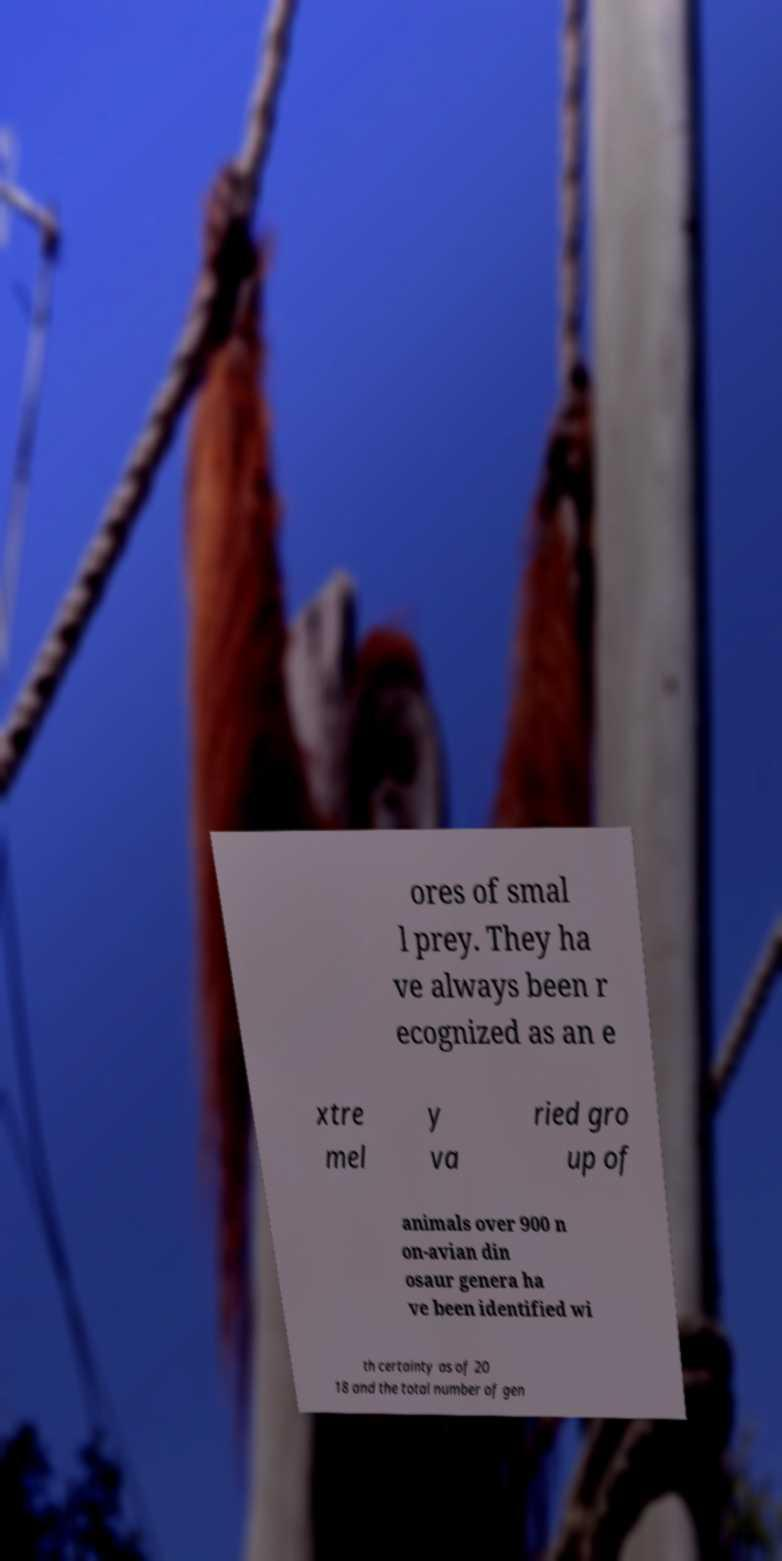What messages or text are displayed in this image? I need them in a readable, typed format. ores of smal l prey. They ha ve always been r ecognized as an e xtre mel y va ried gro up of animals over 900 n on-avian din osaur genera ha ve been identified wi th certainty as of 20 18 and the total number of gen 